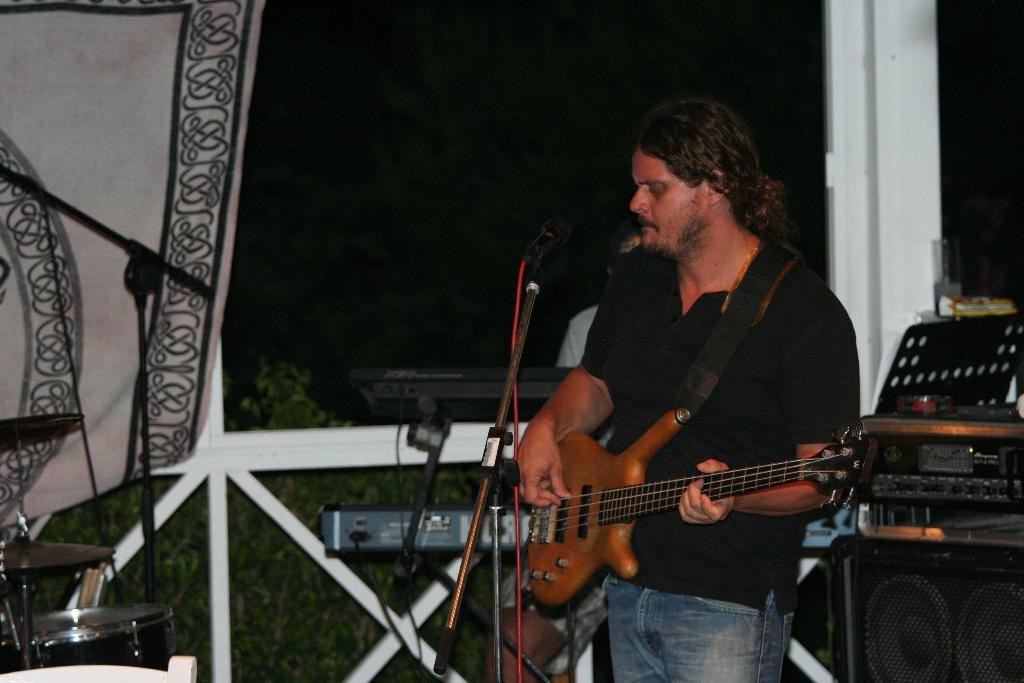What is the main subject of the image? There is a person standing in the image. What is the person doing in the image? The person is playing musical instruments. Can you describe the background of the image? There is another person visible in the background of the image. How many musical instruments can be seen in the image? There are multiple musical instruments in the image. What type of honey is being poured into the glass in the image? There is no honey or glass present in the image; it features a person playing musical instruments. 